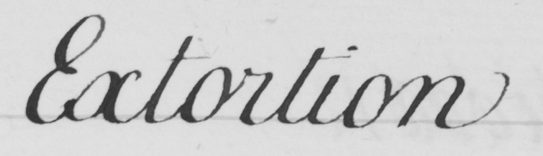Please transcribe the handwritten text in this image. Extortion 